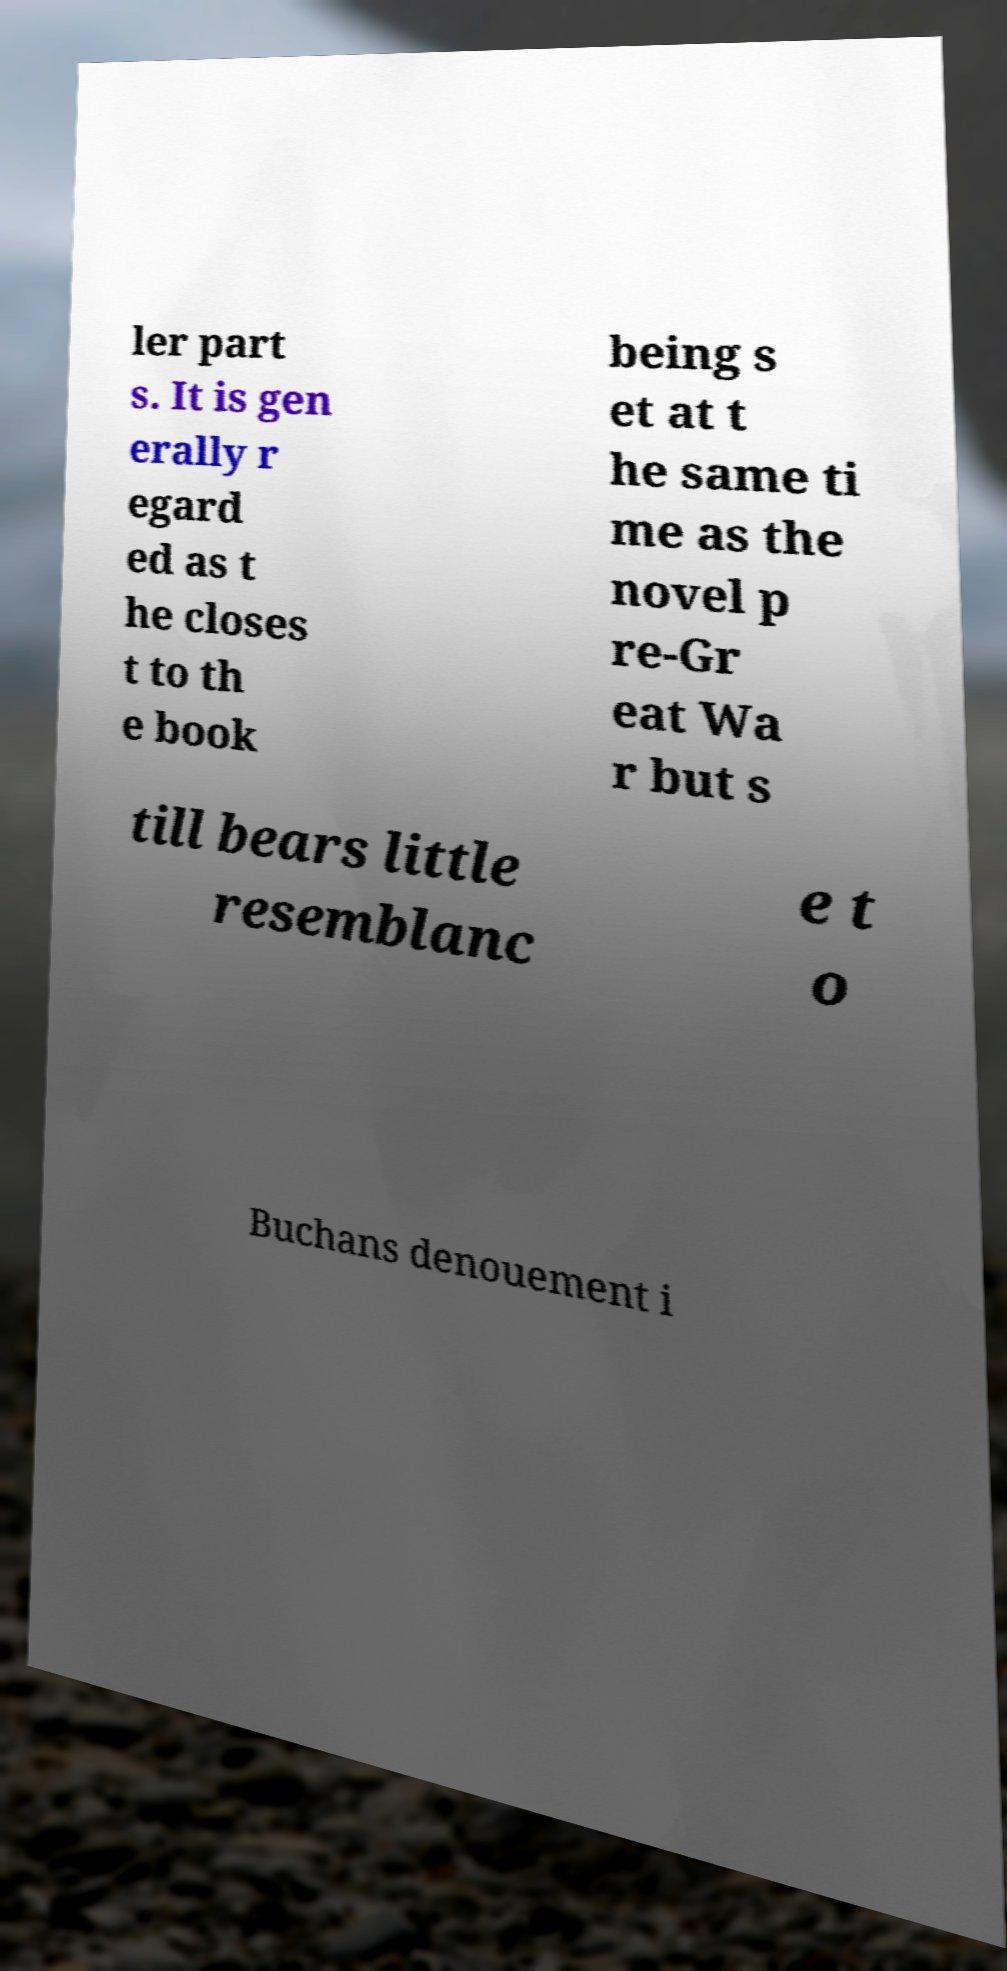Can you accurately transcribe the text from the provided image for me? ler part s. It is gen erally r egard ed as t he closes t to th e book being s et at t he same ti me as the novel p re-Gr eat Wa r but s till bears little resemblanc e t o Buchans denouement i 